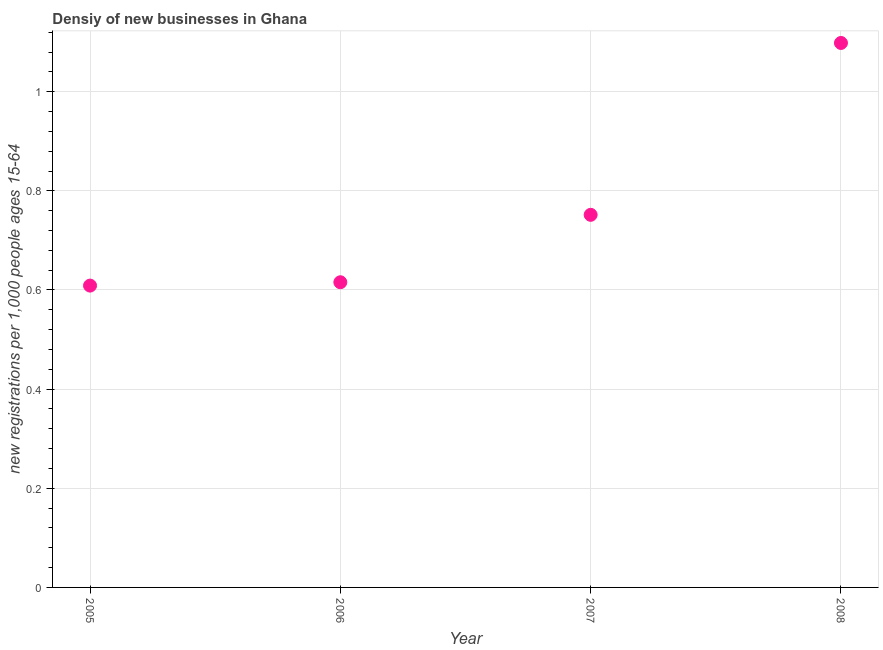What is the density of new business in 2005?
Your answer should be compact. 0.61. Across all years, what is the maximum density of new business?
Your answer should be very brief. 1.1. Across all years, what is the minimum density of new business?
Your answer should be compact. 0.61. In which year was the density of new business maximum?
Your answer should be very brief. 2008. What is the sum of the density of new business?
Offer a very short reply. 3.07. What is the difference between the density of new business in 2005 and 2008?
Provide a succinct answer. -0.49. What is the average density of new business per year?
Ensure brevity in your answer.  0.77. What is the median density of new business?
Provide a short and direct response. 0.68. In how many years, is the density of new business greater than 0.24000000000000002 ?
Offer a very short reply. 4. What is the ratio of the density of new business in 2005 to that in 2006?
Your response must be concise. 0.99. Is the density of new business in 2006 less than that in 2007?
Keep it short and to the point. Yes. What is the difference between the highest and the second highest density of new business?
Keep it short and to the point. 0.35. What is the difference between the highest and the lowest density of new business?
Your answer should be very brief. 0.49. How many dotlines are there?
Offer a terse response. 1. How many years are there in the graph?
Your answer should be compact. 4. Are the values on the major ticks of Y-axis written in scientific E-notation?
Provide a short and direct response. No. Does the graph contain any zero values?
Make the answer very short. No. What is the title of the graph?
Offer a very short reply. Densiy of new businesses in Ghana. What is the label or title of the Y-axis?
Keep it short and to the point. New registrations per 1,0 people ages 15-64. What is the new registrations per 1,000 people ages 15-64 in 2005?
Give a very brief answer. 0.61. What is the new registrations per 1,000 people ages 15-64 in 2006?
Ensure brevity in your answer.  0.62. What is the new registrations per 1,000 people ages 15-64 in 2007?
Your response must be concise. 0.75. What is the new registrations per 1,000 people ages 15-64 in 2008?
Provide a succinct answer. 1.1. What is the difference between the new registrations per 1,000 people ages 15-64 in 2005 and 2006?
Make the answer very short. -0.01. What is the difference between the new registrations per 1,000 people ages 15-64 in 2005 and 2007?
Your answer should be compact. -0.14. What is the difference between the new registrations per 1,000 people ages 15-64 in 2005 and 2008?
Your answer should be very brief. -0.49. What is the difference between the new registrations per 1,000 people ages 15-64 in 2006 and 2007?
Your response must be concise. -0.14. What is the difference between the new registrations per 1,000 people ages 15-64 in 2006 and 2008?
Provide a succinct answer. -0.48. What is the difference between the new registrations per 1,000 people ages 15-64 in 2007 and 2008?
Give a very brief answer. -0.35. What is the ratio of the new registrations per 1,000 people ages 15-64 in 2005 to that in 2007?
Keep it short and to the point. 0.81. What is the ratio of the new registrations per 1,000 people ages 15-64 in 2005 to that in 2008?
Give a very brief answer. 0.55. What is the ratio of the new registrations per 1,000 people ages 15-64 in 2006 to that in 2007?
Give a very brief answer. 0.82. What is the ratio of the new registrations per 1,000 people ages 15-64 in 2006 to that in 2008?
Provide a succinct answer. 0.56. What is the ratio of the new registrations per 1,000 people ages 15-64 in 2007 to that in 2008?
Ensure brevity in your answer.  0.68. 